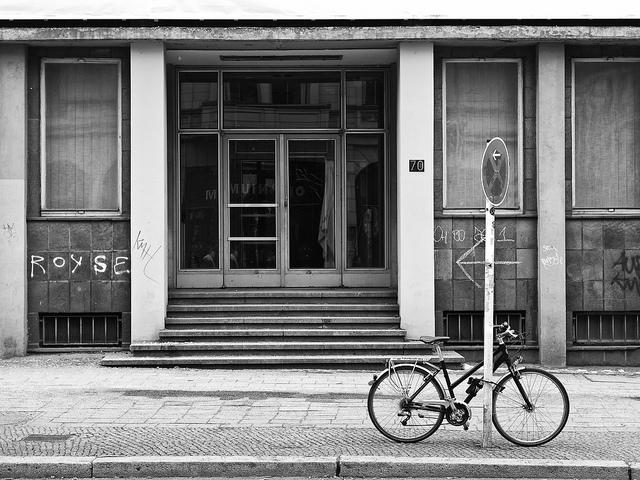How many people in this photo?
Short answer required. 0. Is the photo in black and white?
Write a very short answer. Yes. What is the bicycle chained to?
Keep it brief. Pole. 